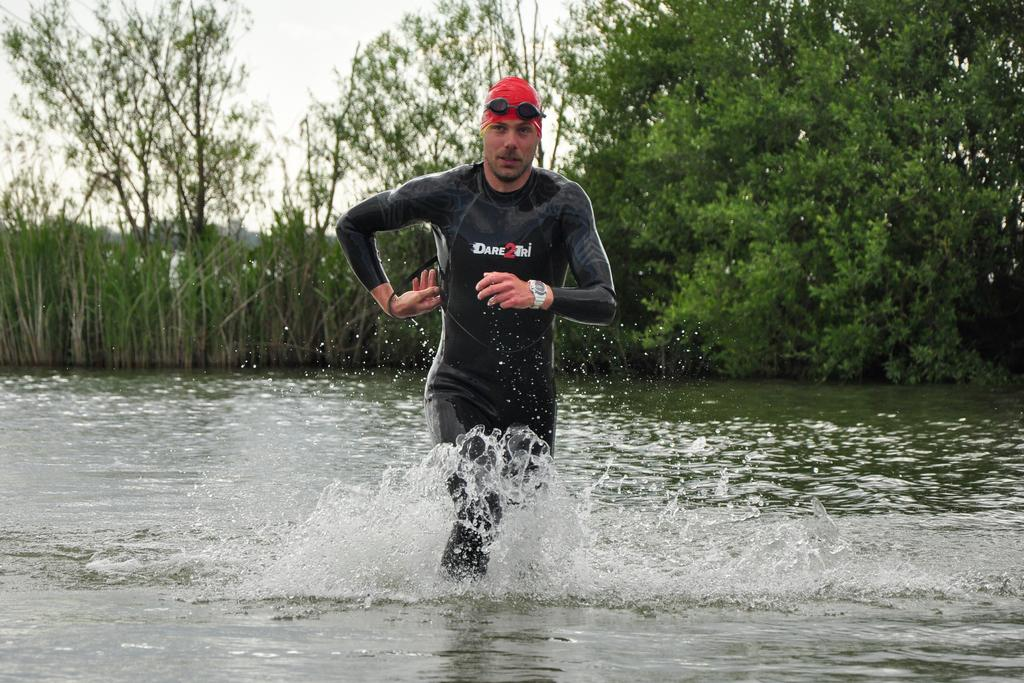Who is present in the image? There is a man in the image. What is the man doing in the image? The man is walking in the water. What can be seen in the background of the image? There is grass, trees, and the sky visible in the background of the image. What type of toothbrush is the man using to play the game in the image? There is no toothbrush or game present in the image; the man is simply walking in the water. 